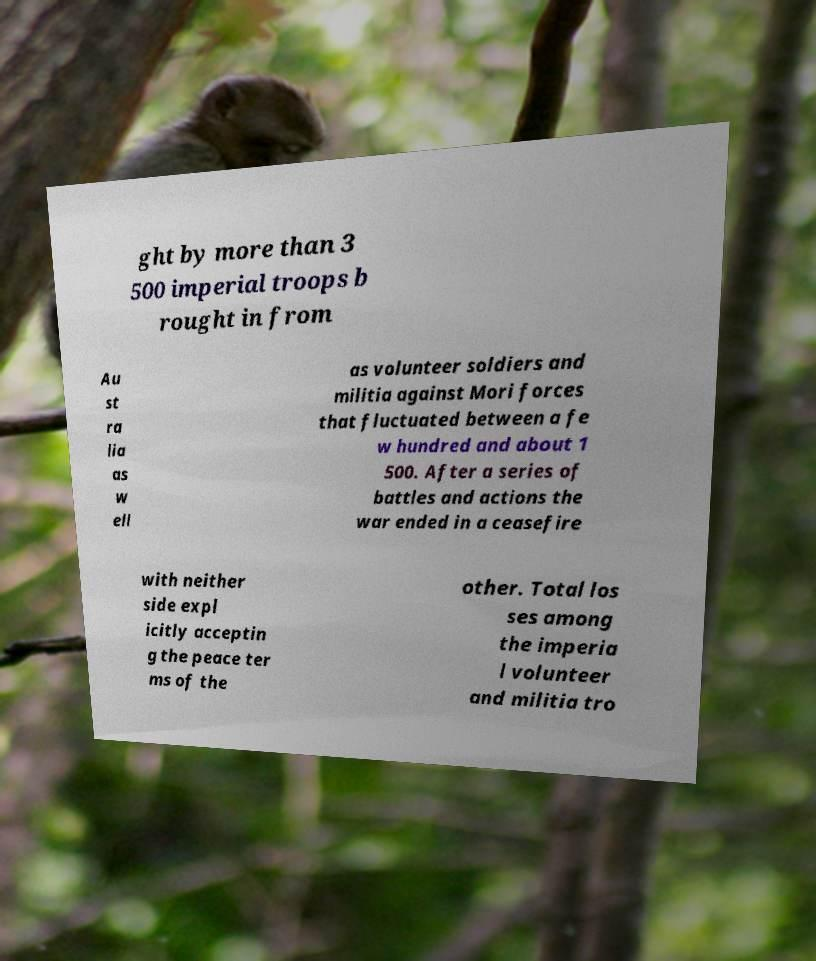Please read and relay the text visible in this image. What does it say? ght by more than 3 500 imperial troops b rought in from Au st ra lia as w ell as volunteer soldiers and militia against Mori forces that fluctuated between a fe w hundred and about 1 500. After a series of battles and actions the war ended in a ceasefire with neither side expl icitly acceptin g the peace ter ms of the other. Total los ses among the imperia l volunteer and militia tro 